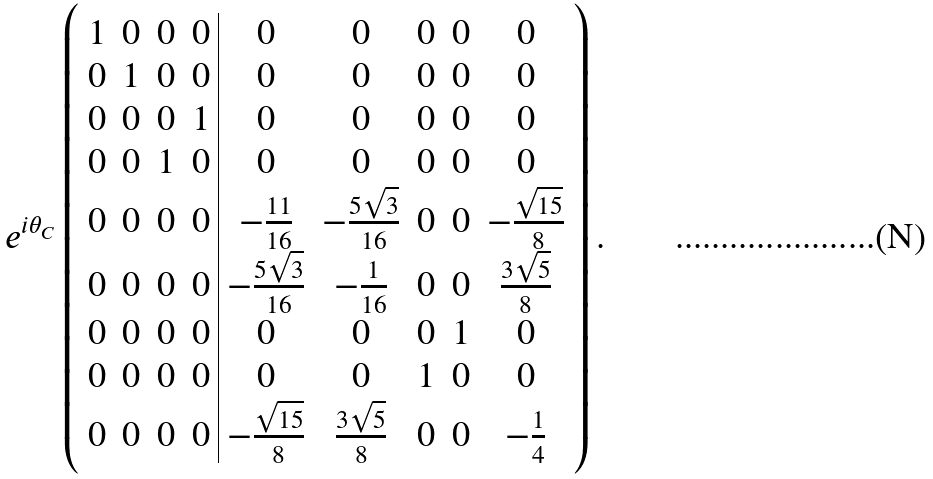Convert formula to latex. <formula><loc_0><loc_0><loc_500><loc_500>e ^ { i \theta _ { C } } \left ( \begin{array} { c c c c | c c c c c } 1 & 0 & 0 & 0 & 0 & 0 & 0 & 0 & 0 \\ 0 & 1 & 0 & 0 & 0 & 0 & 0 & 0 & 0 \\ 0 & 0 & 0 & 1 & 0 & 0 & 0 & 0 & 0 \\ 0 & 0 & 1 & 0 & 0 & 0 & 0 & 0 & 0 \\ 0 & 0 & 0 & 0 & - \frac { 1 1 } { 1 6 } & - \frac { 5 \sqrt { 3 } } { 1 6 } & 0 & 0 & - \frac { \sqrt { 1 5 } } { 8 } \\ 0 & 0 & 0 & 0 & - \frac { 5 \sqrt { 3 } } { 1 6 } & - \frac { 1 } { 1 6 } & 0 & 0 & \frac { 3 \sqrt { 5 } } { 8 } \\ 0 & 0 & 0 & 0 & 0 & 0 & 0 & 1 & 0 \\ 0 & 0 & 0 & 0 & 0 & 0 & 1 & 0 & 0 \\ 0 & 0 & 0 & 0 & - \frac { \sqrt { 1 5 } } { 8 } & \frac { 3 \sqrt { 5 } } { 8 } & 0 & 0 & - \frac { 1 } { 4 } \end{array} \right ) .</formula> 